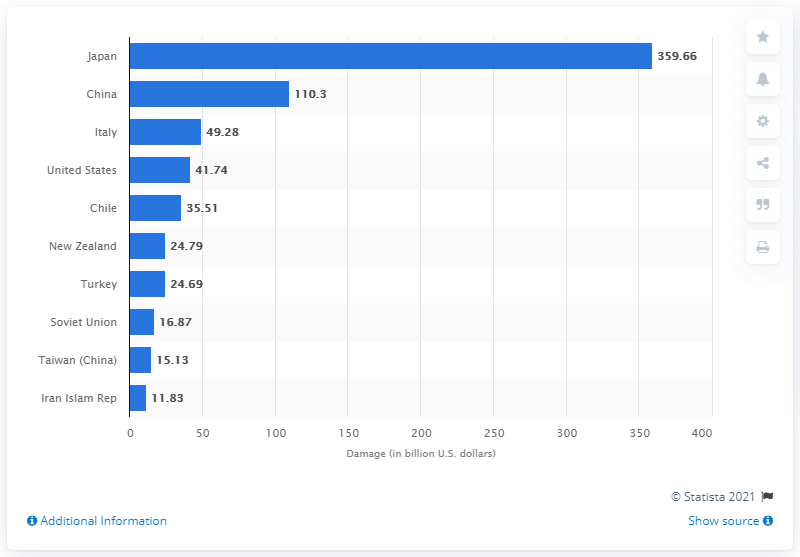Specify some key components in this picture. Japan suffered a significant financial loss as a result of earthquakes between 1900 and 2016, with a total of 359.66 million USD in damages. 